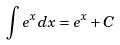<formula> <loc_0><loc_0><loc_500><loc_500>\int e ^ { x } d x = e ^ { x } + C</formula> 